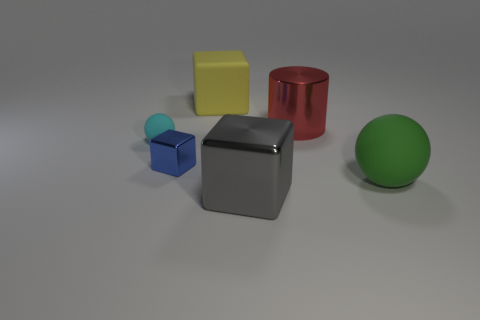What size is the rubber cube?
Your answer should be compact. Large. Is there anything else that has the same shape as the big red thing?
Give a very brief answer. No. Are there any rubber objects on the right side of the large shiny object that is in front of the blue cube?
Your answer should be very brief. Yes. Are there fewer big red shiny things behind the big green object than shiny objects that are to the right of the large yellow cube?
Provide a short and direct response. Yes. What is the size of the ball to the left of the matte object on the right side of the large shiny thing to the right of the large gray metallic object?
Make the answer very short. Small. Is the size of the metal object behind the cyan thing the same as the yellow object?
Provide a short and direct response. Yes. Are there more tiny blue objects than big blue metallic objects?
Offer a terse response. Yes. What material is the cube right of the big rubber thing left of the ball that is in front of the tiny cyan matte sphere made of?
Ensure brevity in your answer.  Metal. Are there any big cylinders that have the same color as the tiny sphere?
Provide a succinct answer. No. There is a yellow matte object that is the same size as the green matte ball; what is its shape?
Provide a short and direct response. Cube. 